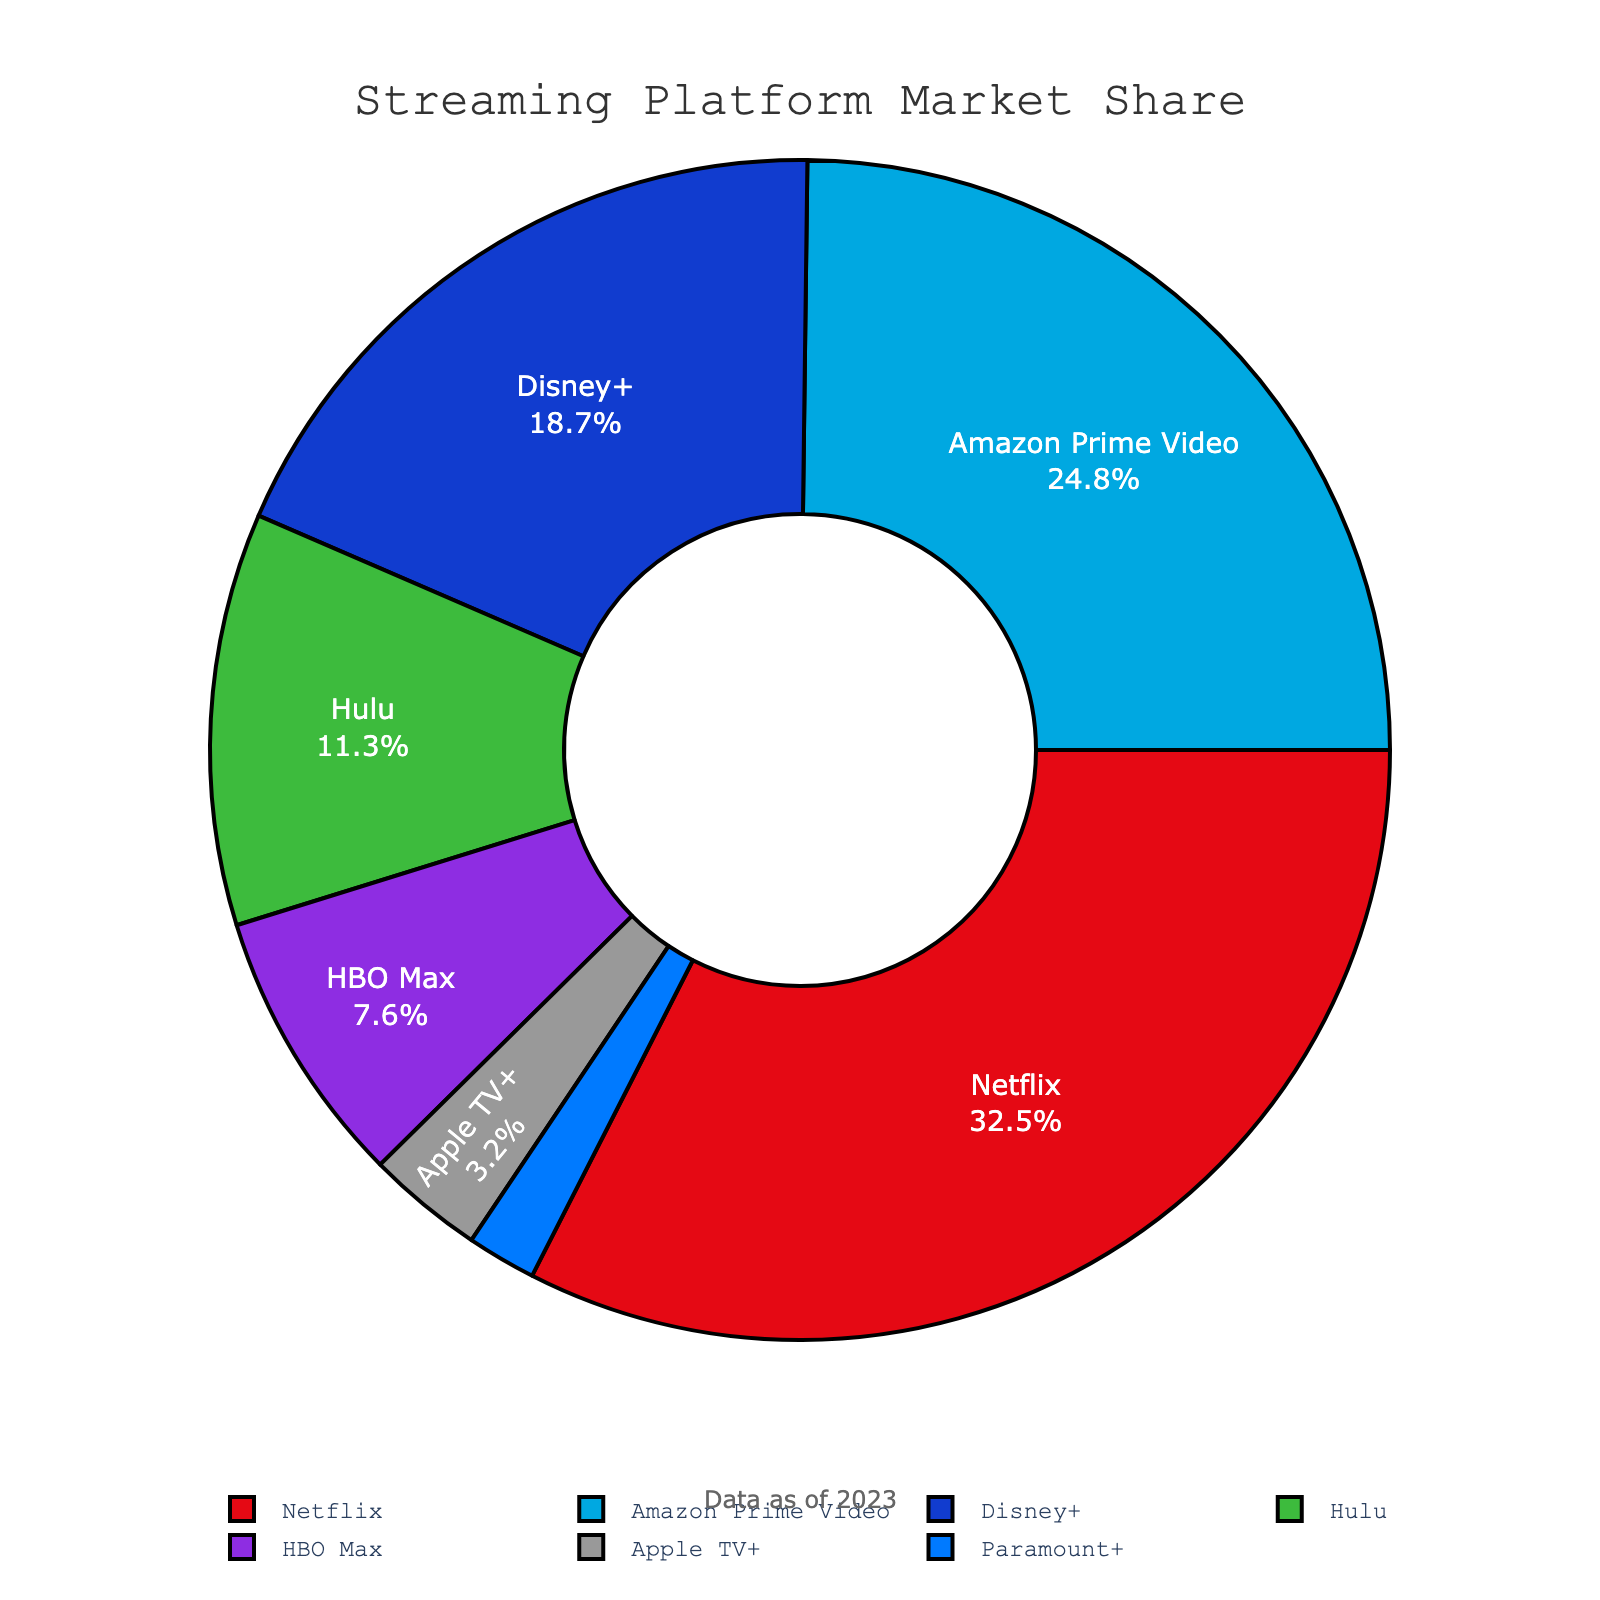Which streaming service has the highest percentage of subscribers? The pie chart shows that Netflix has the largest segment. By observing the labels, Netflix leads with a 32.5% share of subscribers.
Answer: Netflix What is the combined percentage of subscribers for Disney+ and Hulu? By adding the percentages of Disney+ (18.7%) and Hulu (11.3%), we get 18.7 + 11.3 = 30.
Answer: 30 How does the subscriber percentage of Amazon Prime Video compare to that of HBO Max? Amazon Prime Video has 24.8% while HBO Max has 7.6%. Since 24.8 is greater than 7.6, Amazon Prime Video has a higher percentage of subscribers.
Answer: Amazon Prime Video has a higher percentage Which streaming service has the smallest share of subscribers? The pie chart shows that Paramount+ has the smallest segment with a 1.9% share of subscribers.
Answer: Paramount+ Is the percentage of subscribers for Amazon Prime Video greater or less than the sum of Apple TV+ and Hulu's subscribers? The percentage of Amazon Prime Video is 24.8%. The sum of Apple TV+ (3.2%) and Hulu (11.3%) is 3.2 + 11.3 = 14.5%. Since 24.8 is greater than 14.5, Amazon Prime Video has a greater percentage.
Answer: Greater What is the combined market share of Netflix, Disney+, and Hulu? By adding the percentages of Netflix (32.5%), Disney+ (18.7%), and Hulu (11.3%), we get 32.5 + 18.7 + 11.3 = 62.5.
Answer: 62.5 Are there more subscribers to HBO Max or Apple TV+? By looking at the respective percentages, HBO Max has 7.6% and Apple TV+ has 3.2%. Since 7.6 is greater than 3.2, HBO Max has more subscribers.
Answer: HBO Max Does any single service have over one-third of the market share? One-third of 100% is approximately 33.33%. The largest share is Netflix with 32.5%, which is below one-third.
Answer: No How many services have a subscriber percentage less than 10%? The services with less than 10% are HBO Max (7.6%), Apple TV+ (3.2%), and Paramount+ (1.9%). Counting these, there are three services with less than 10%.
Answer: 3 